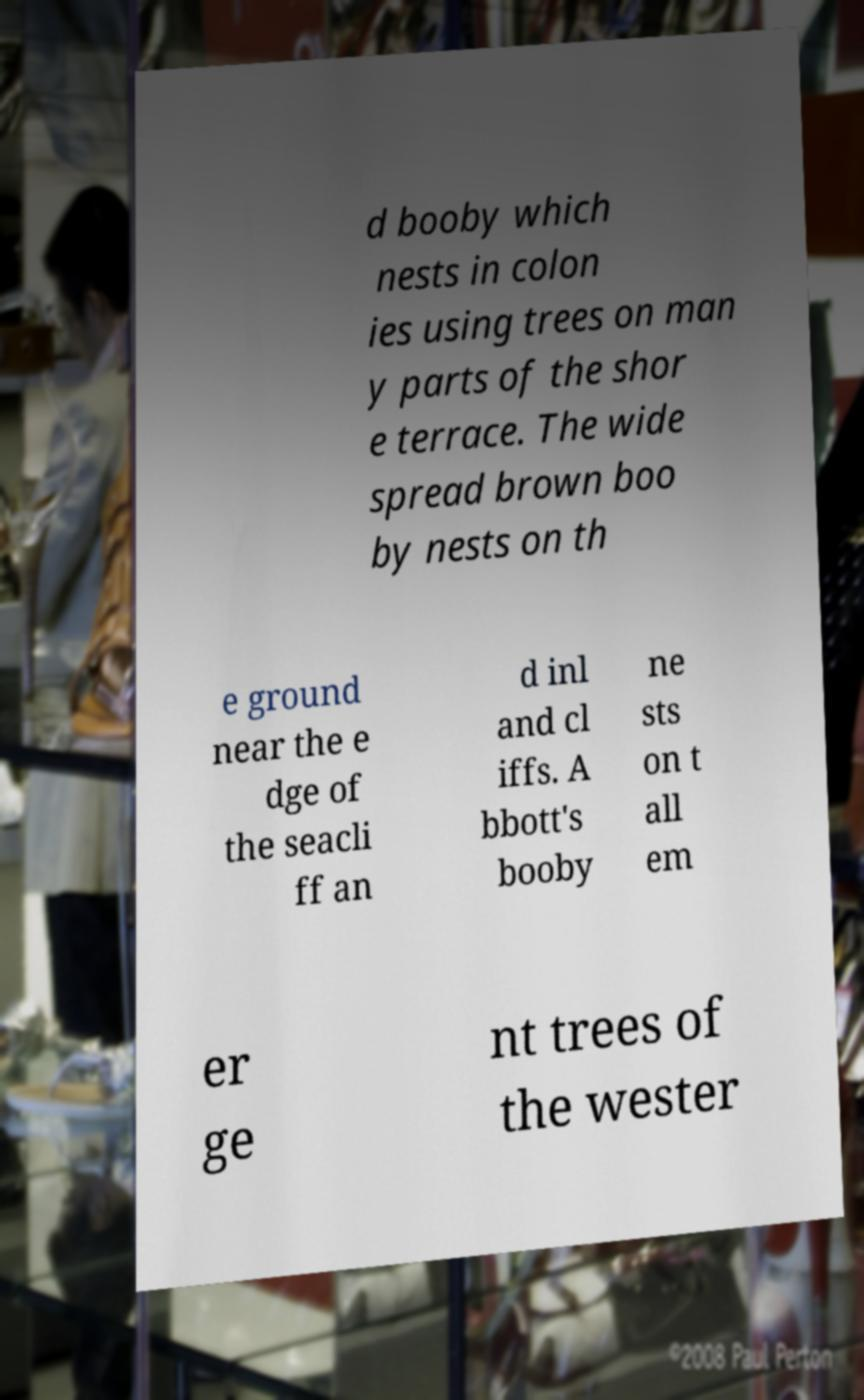Please read and relay the text visible in this image. What does it say? d booby which nests in colon ies using trees on man y parts of the shor e terrace. The wide spread brown boo by nests on th e ground near the e dge of the seacli ff an d inl and cl iffs. A bbott's booby ne sts on t all em er ge nt trees of the wester 